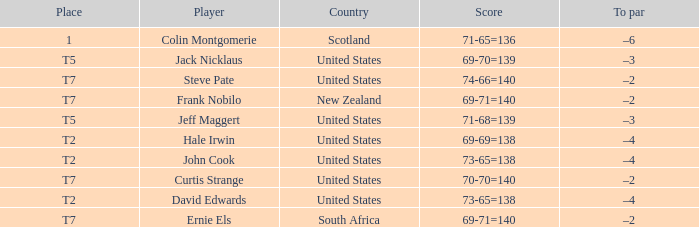Frank Nobilo plays for what country? New Zealand. 